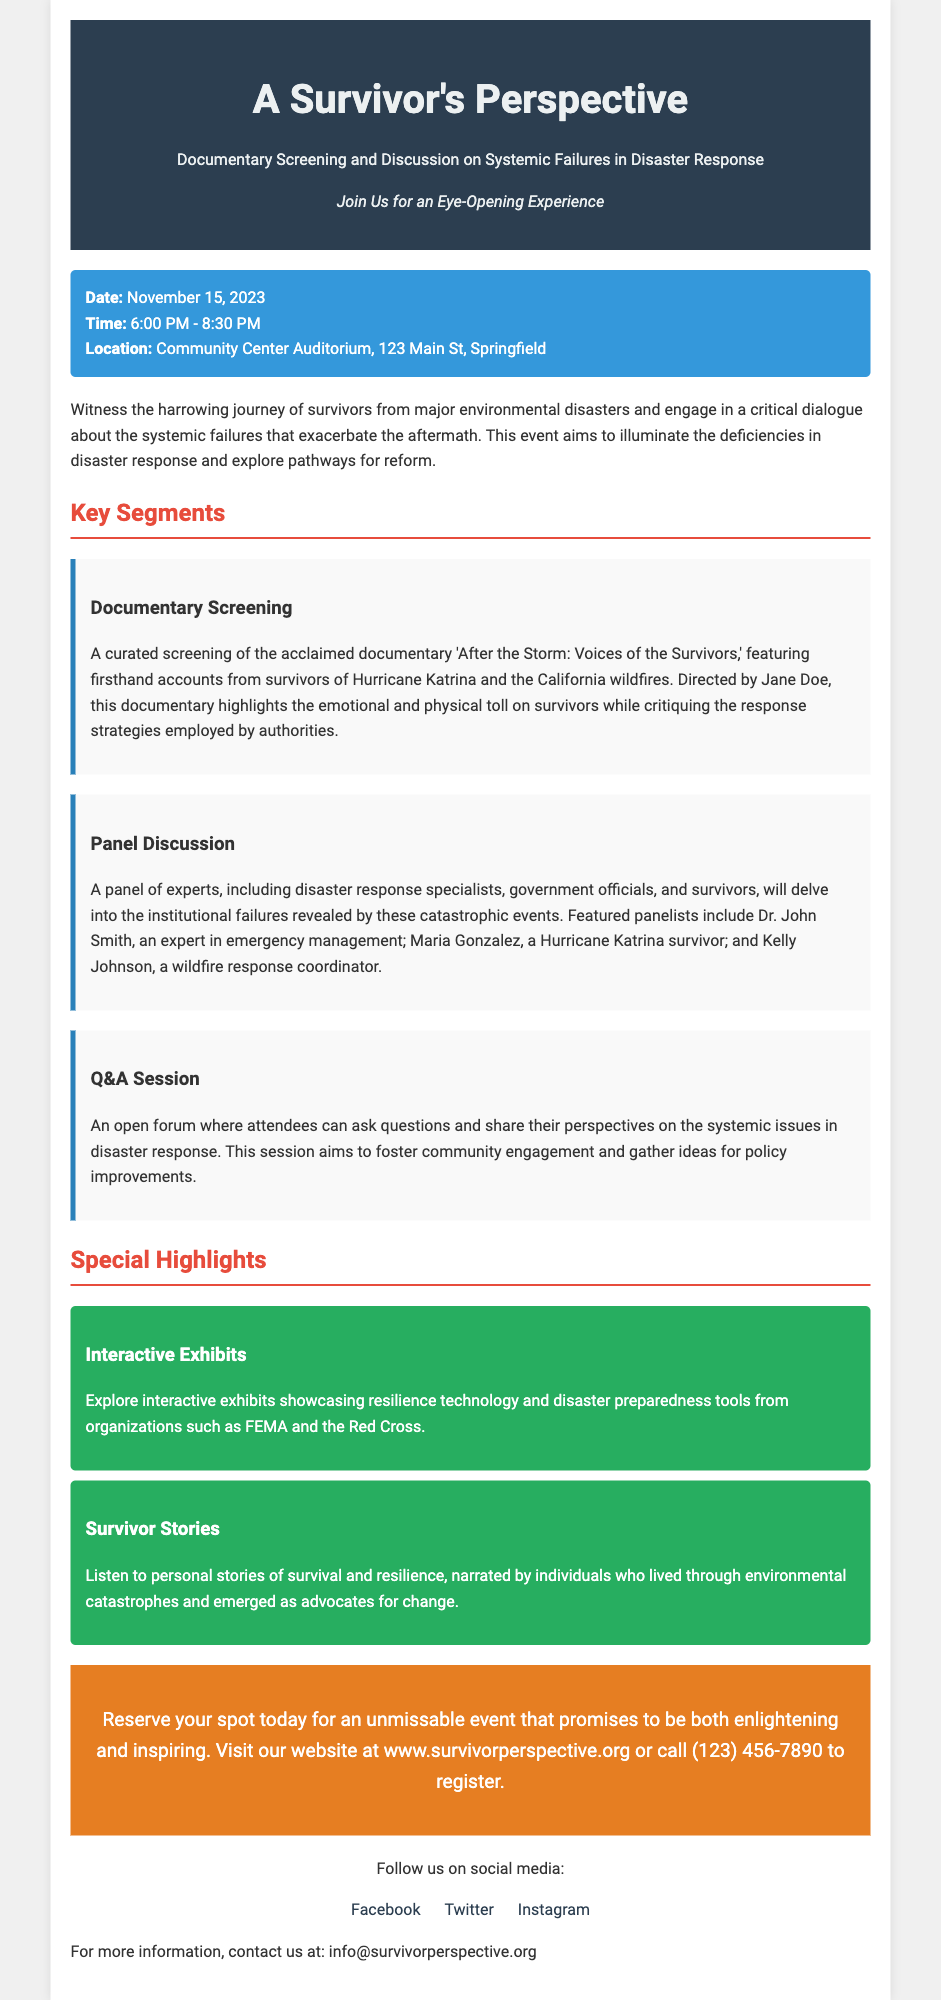What is the date of the event? The date is specified in the event details section of the document.
Answer: November 15, 2023 What time does the event start? The starting time is mentioned in the event details section.
Answer: 6:00 PM Who directed the documentary 'After the Storm: Voices of the Survivors'? The document lists the director in the documentary screening segment.
Answer: Jane Doe What type of event is being discussed? The type of event is described in the header of the document.
Answer: Documentary Screening and Discussion What will attendees explore during the interactive exhibits? The document mentions what the interactive exhibits will showcase.
Answer: Resilience technology and disaster preparedness tools Who is one of the featured panelists? The names of featured panelists are provided in the panel discussion segment of the document.
Answer: Maria Gonzalez What is the call to action for reserving a spot? The call to action is found in the CTA section of the document.
Answer: Reserve your spot today What does the Q&A session aim to foster? The purpose of the Q&A session is stated in its description.
Answer: Community engagement and gathering ideas for policy improvements 